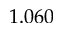Convert formula to latex. <formula><loc_0><loc_0><loc_500><loc_500>1 . 0 6 0</formula> 